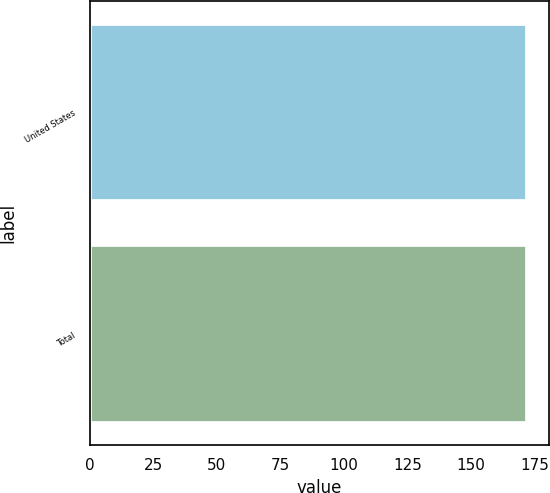<chart> <loc_0><loc_0><loc_500><loc_500><bar_chart><fcel>United States<fcel>Total<nl><fcel>172<fcel>172.1<nl></chart> 